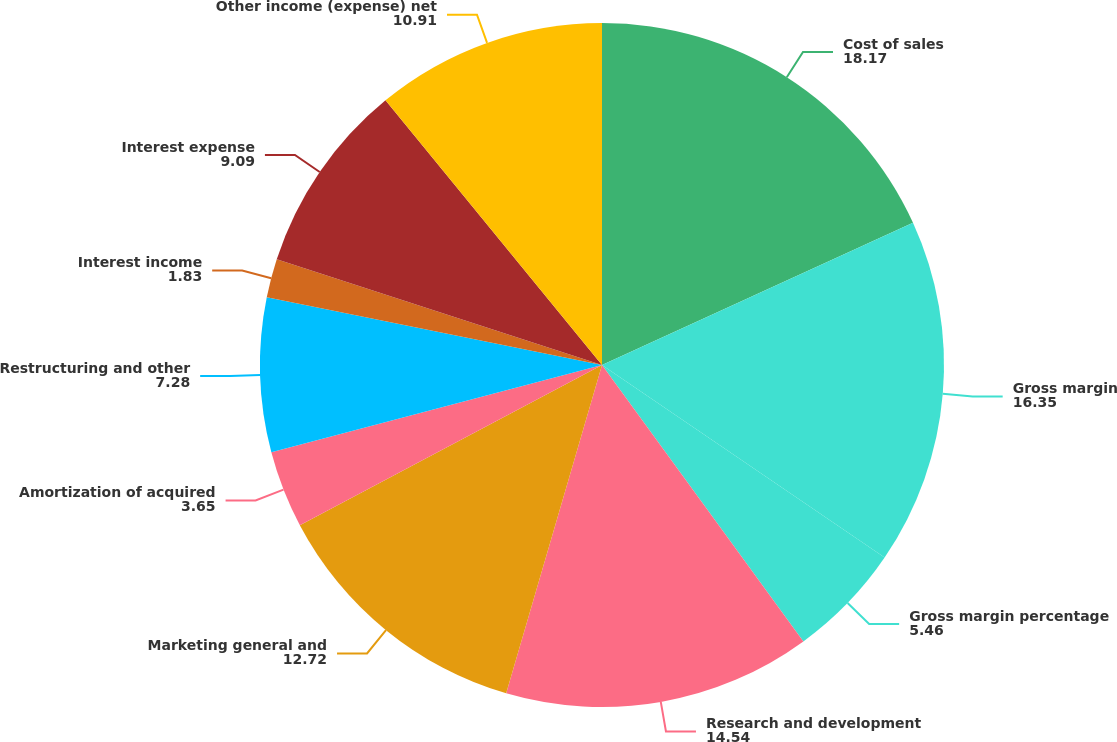Convert chart. <chart><loc_0><loc_0><loc_500><loc_500><pie_chart><fcel>Cost of sales<fcel>Gross margin<fcel>Gross margin percentage<fcel>Research and development<fcel>Marketing general and<fcel>Amortization of acquired<fcel>Restructuring and other<fcel>Interest income<fcel>Interest expense<fcel>Other income (expense) net<nl><fcel>18.17%<fcel>16.35%<fcel>5.46%<fcel>14.54%<fcel>12.72%<fcel>3.65%<fcel>7.28%<fcel>1.83%<fcel>9.09%<fcel>10.91%<nl></chart> 